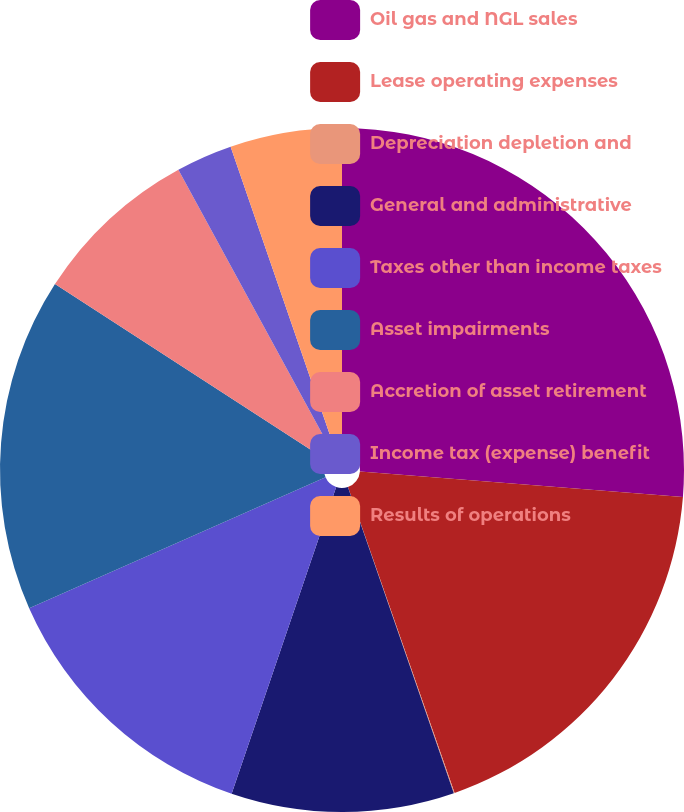<chart> <loc_0><loc_0><loc_500><loc_500><pie_chart><fcel>Oil gas and NGL sales<fcel>Lease operating expenses<fcel>Depreciation depletion and<fcel>General and administrative<fcel>Taxes other than income taxes<fcel>Asset impairments<fcel>Accretion of asset retirement<fcel>Income tax (expense) benefit<fcel>Results of operations<nl><fcel>26.26%<fcel>18.4%<fcel>0.04%<fcel>10.53%<fcel>13.15%<fcel>15.77%<fcel>7.91%<fcel>2.66%<fcel>5.28%<nl></chart> 